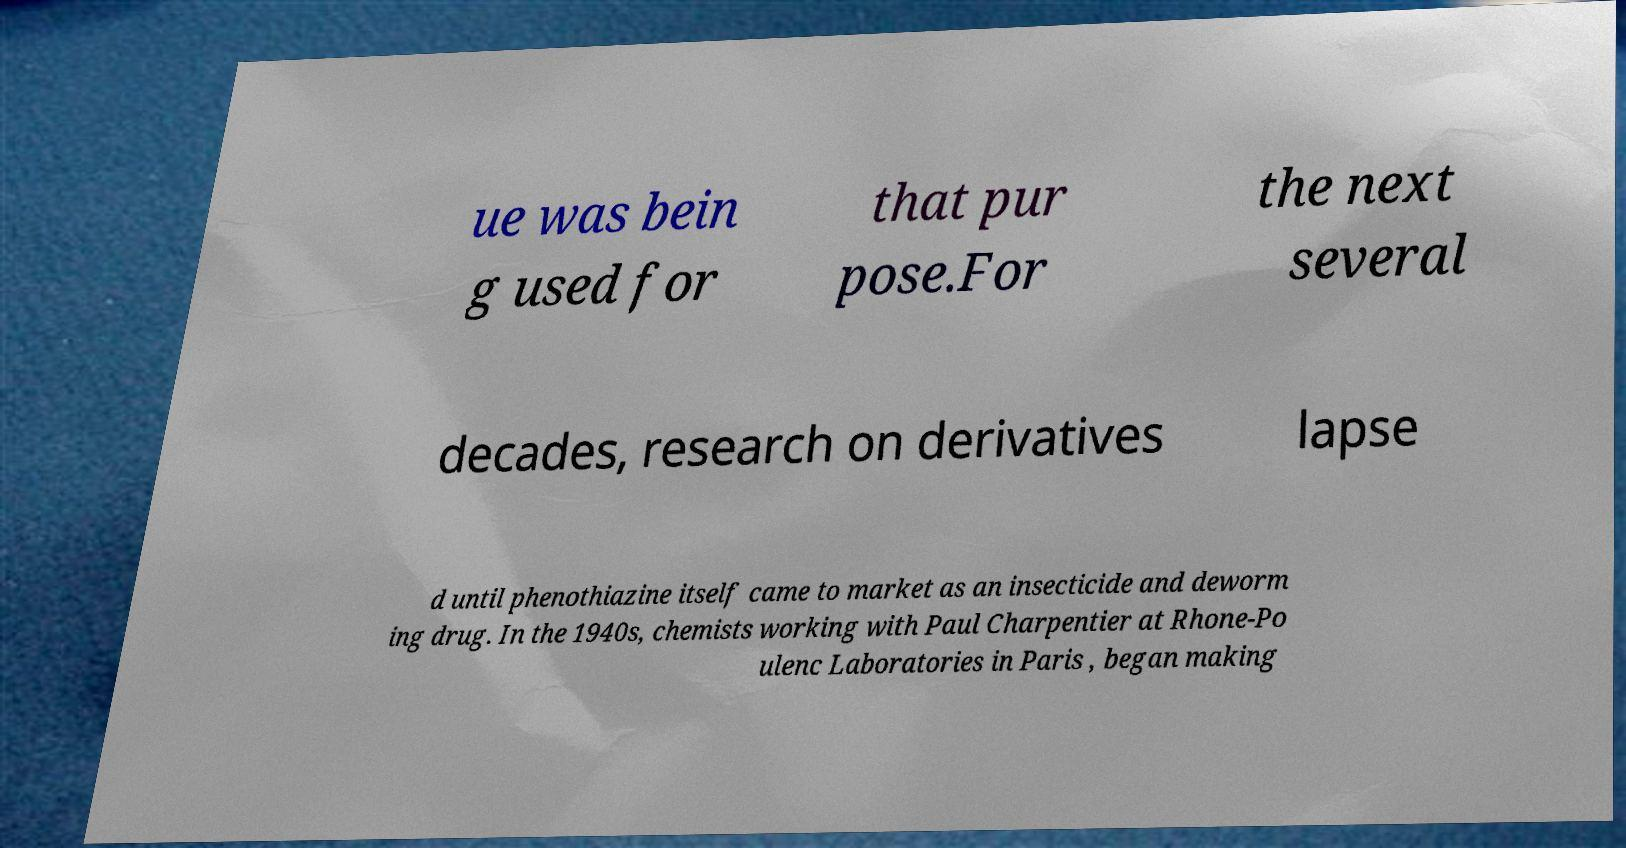Could you extract and type out the text from this image? ue was bein g used for that pur pose.For the next several decades, research on derivatives lapse d until phenothiazine itself came to market as an insecticide and deworm ing drug. In the 1940s, chemists working with Paul Charpentier at Rhone-Po ulenc Laboratories in Paris , began making 